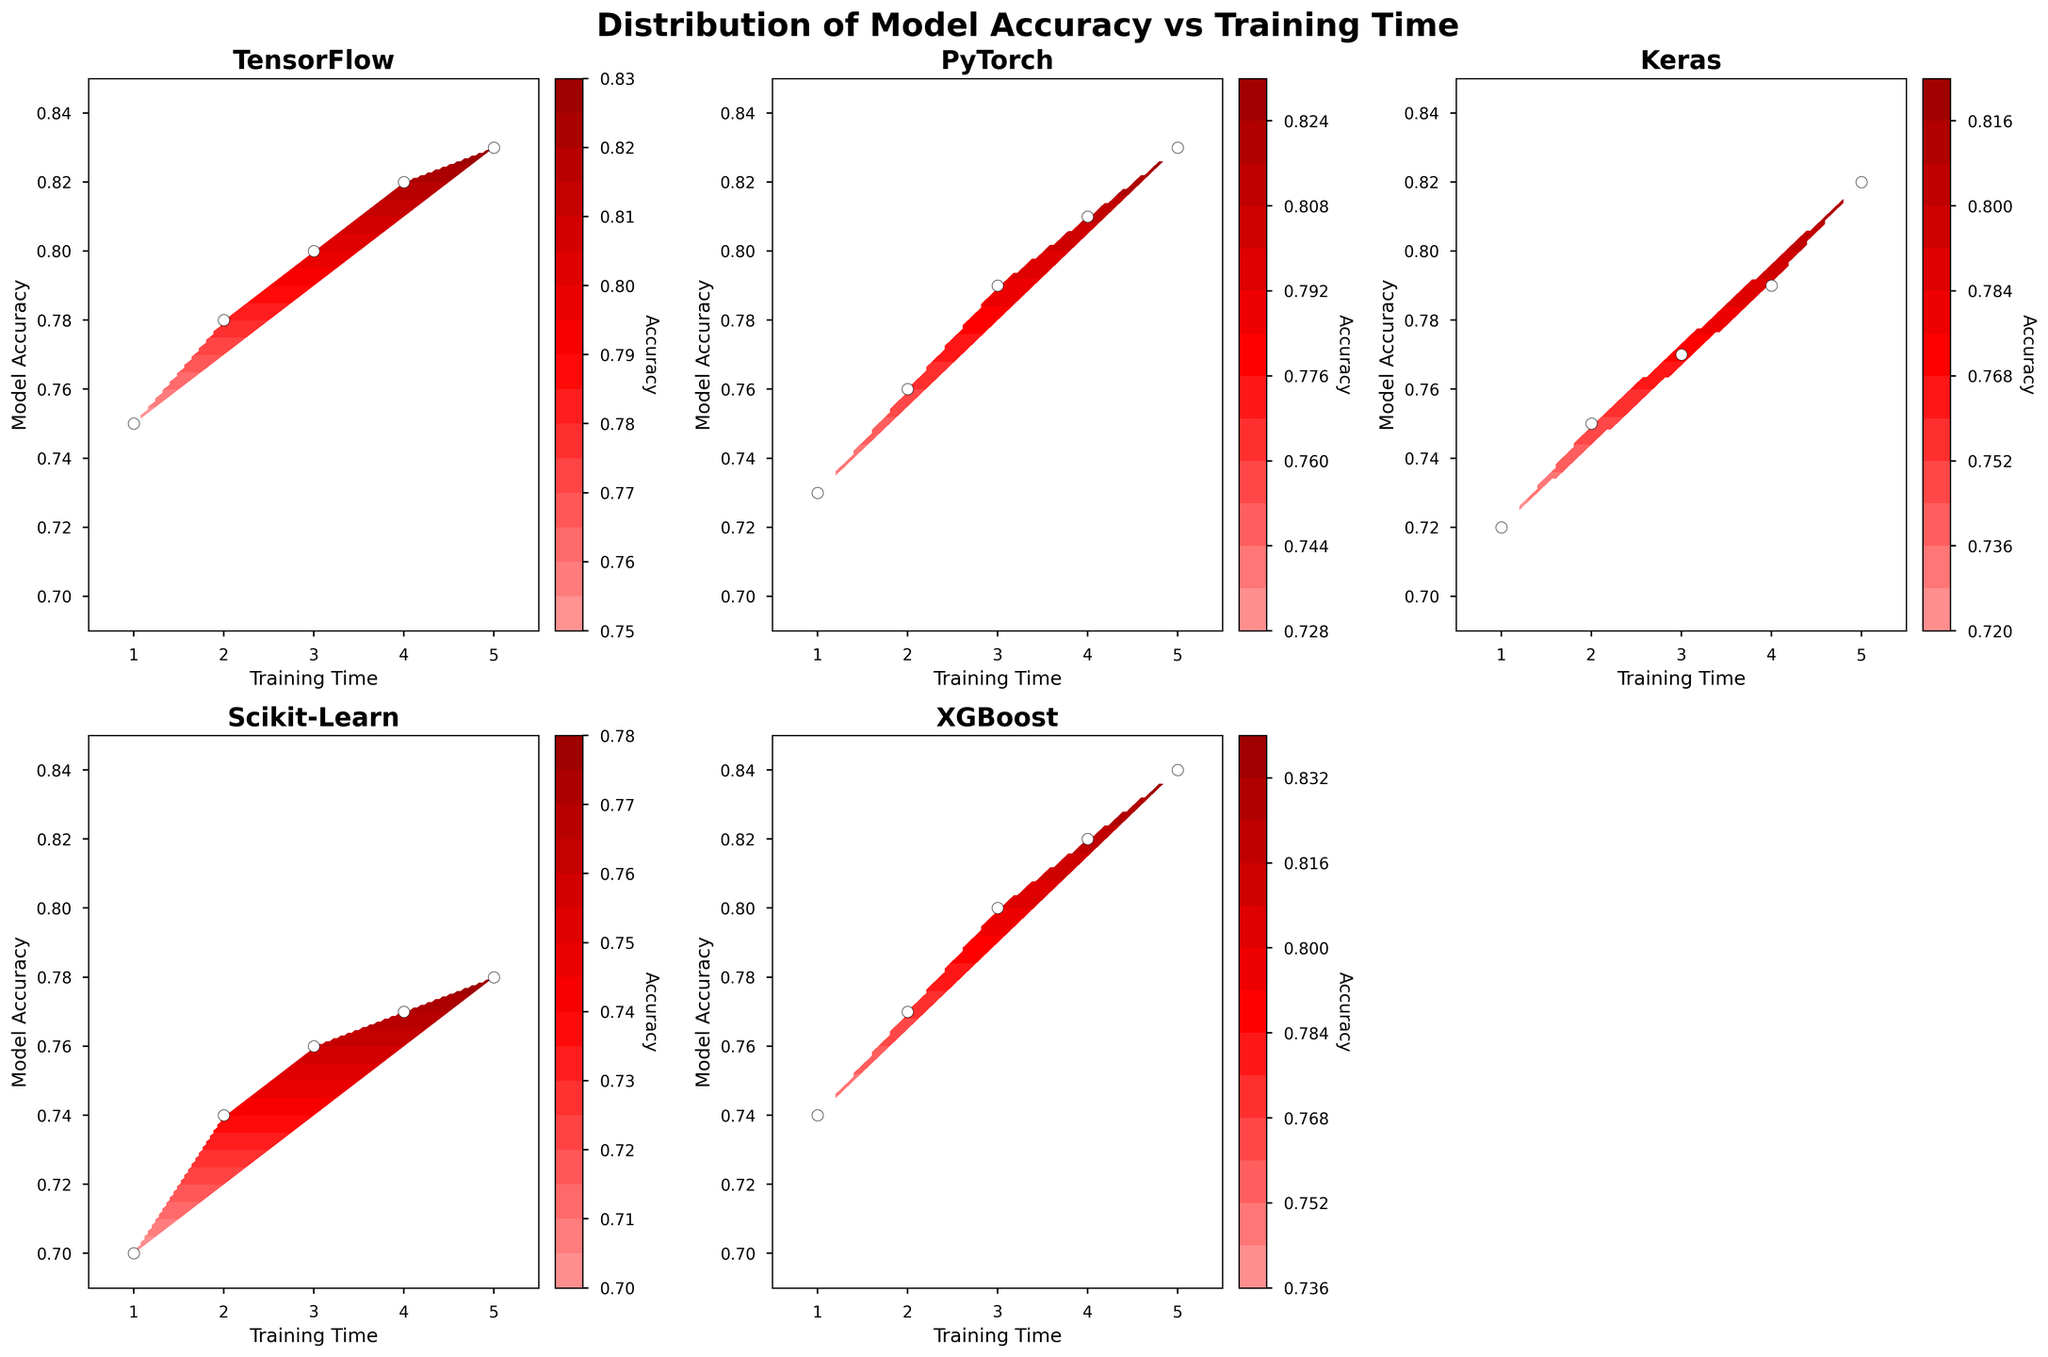What is the title of the figure? The title of the figure is typically located at the top center of the plot. In this case, it should be read directly from the figure.
Answer: Distribution of Model Accuracy vs Training Time How many subplots are there in the figure? The number of subplots can be determined by counting the individual plots within the entire figure layout.
Answer: 5 Which framework shows the highest model accuracy at the maximum training time? By looking at the maximum values on the training time axis for each framework and comparing the corresponding model accuracy values, the highest value is identified.
Answer: XGBoost What is the range of model accuracy values for TensorFlow? To find the range, note the minimum and maximum model accuracy values for TensorFlow on its respective subplot. TensorFlow ranges from 0.75 to 0.83.
Answer: 0.75 to 0.83 Which framework reaches an accuracy of 0.82 after 5 units of training time? By examining each subplot for the framework that reaches exactly 0.82 model accuracy at 5 units of training time, the correct framework is identified.
Answer: TensorFlow and XGBoost Does PyTorch achieve a model accuracy greater than Scikit-Learn within the same training period? Compare the model accuracy values of PyTorch and Scikit-Learn at the same points on the training time axis. PyTorch surpasses Scikit-Learn consistently.
Answer: Yes At what specific training time does Keras reach a model accuracy of 0.79? By observing the contour plot for Keras and finding the training time corresponding to 0.79 model accuracy, it can be identified.
Answer: 4 units Which framework requires the least training time to exceed 0.80 model accuracy? By checking the subplots for the first instance where each framework exceeds 0.80 model accuracy and identifying the training time, the minimum time is determined.
Answer: XGBoost What is the color representation for the highest accuracy values in the custom colormap? The custom colormap's coloring at the highest contour levels can be seen and described.
Answer: Dark red How does the model accuracy trend for Scikit-Learn compare to TensorFlow as training time increases? By directly comparing the trends in the contour plots for both frameworks as training time progresses, TensorFlow shows a more significant increase in accuracy.
Answer: TensorFlow increases more rapidly 